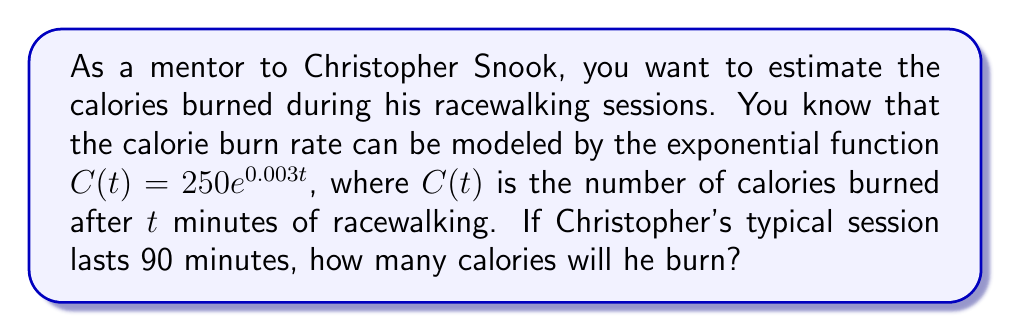Give your solution to this math problem. To solve this problem, we'll follow these steps:

1) We are given the exponential function for calorie burn:
   $C(t) = 250e^{0.003t}$

2) We need to find $C(90)$ since Christopher's session lasts 90 minutes:
   $C(90) = 250e^{0.003(90)}$

3) Let's evaluate this step by step:
   $C(90) = 250e^{0.27}$

4) Now, we need to calculate $e^{0.27}$:
   $e^{0.27} \approx 1.31$

5) Finally, we multiply:
   $C(90) = 250 * 1.31 = 327.5$

6) Rounding to the nearest calorie:
   $C(90) \approx 328$ calories

Therefore, Christopher will burn approximately 328 calories during his 90-minute racewalking session.
Answer: 328 calories 